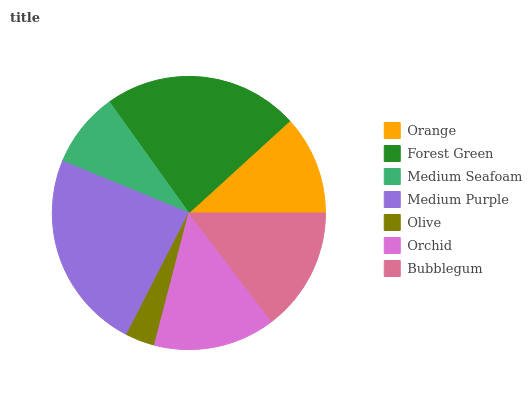Is Olive the minimum?
Answer yes or no. Yes. Is Medium Purple the maximum?
Answer yes or no. Yes. Is Forest Green the minimum?
Answer yes or no. No. Is Forest Green the maximum?
Answer yes or no. No. Is Forest Green greater than Orange?
Answer yes or no. Yes. Is Orange less than Forest Green?
Answer yes or no. Yes. Is Orange greater than Forest Green?
Answer yes or no. No. Is Forest Green less than Orange?
Answer yes or no. No. Is Orchid the high median?
Answer yes or no. Yes. Is Orchid the low median?
Answer yes or no. Yes. Is Medium Seafoam the high median?
Answer yes or no. No. Is Medium Purple the low median?
Answer yes or no. No. 